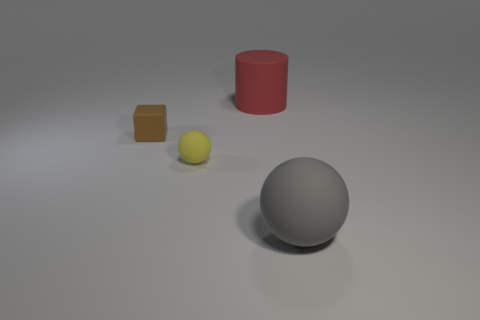Does the matte cube have the same color as the large rubber ball?
Provide a short and direct response. No. What size is the matte sphere right of the large matte object behind the matte cube?
Give a very brief answer. Large. How many rubber spheres have the same color as the cube?
Keep it short and to the point. 0. What shape is the small brown object that is in front of the big thing that is behind the small brown matte cube?
Provide a short and direct response. Cube. How many small balls have the same material as the brown thing?
Make the answer very short. 1. There is a small block to the left of the tiny yellow ball; what is it made of?
Your answer should be compact. Rubber. There is a large thing to the left of the big rubber thing on the right side of the large rubber object behind the brown object; what is its shape?
Make the answer very short. Cylinder. Is the number of cylinders that are right of the gray sphere less than the number of red rubber cylinders that are in front of the tiny sphere?
Offer a terse response. No. Are there any other things that have the same shape as the small brown matte thing?
Make the answer very short. No. The other matte object that is the same shape as the yellow matte object is what color?
Offer a very short reply. Gray. 